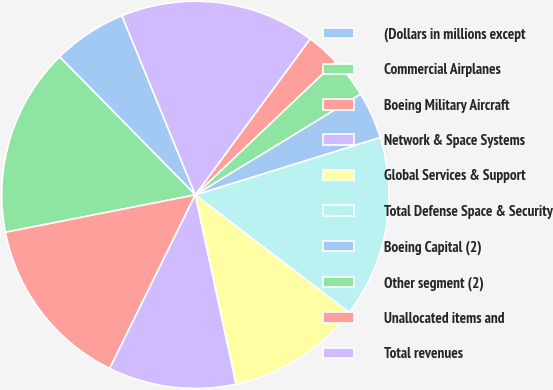<chart> <loc_0><loc_0><loc_500><loc_500><pie_chart><fcel>(Dollars in millions except<fcel>Commercial Airplanes<fcel>Boeing Military Aircraft<fcel>Network & Space Systems<fcel>Global Services & Support<fcel>Total Defense Space & Security<fcel>Boeing Capital (2)<fcel>Other segment (2)<fcel>Unallocated items and<fcel>Total revenues<nl><fcel>6.18%<fcel>15.73%<fcel>14.61%<fcel>10.67%<fcel>11.24%<fcel>15.17%<fcel>3.93%<fcel>3.37%<fcel>2.81%<fcel>16.29%<nl></chart> 